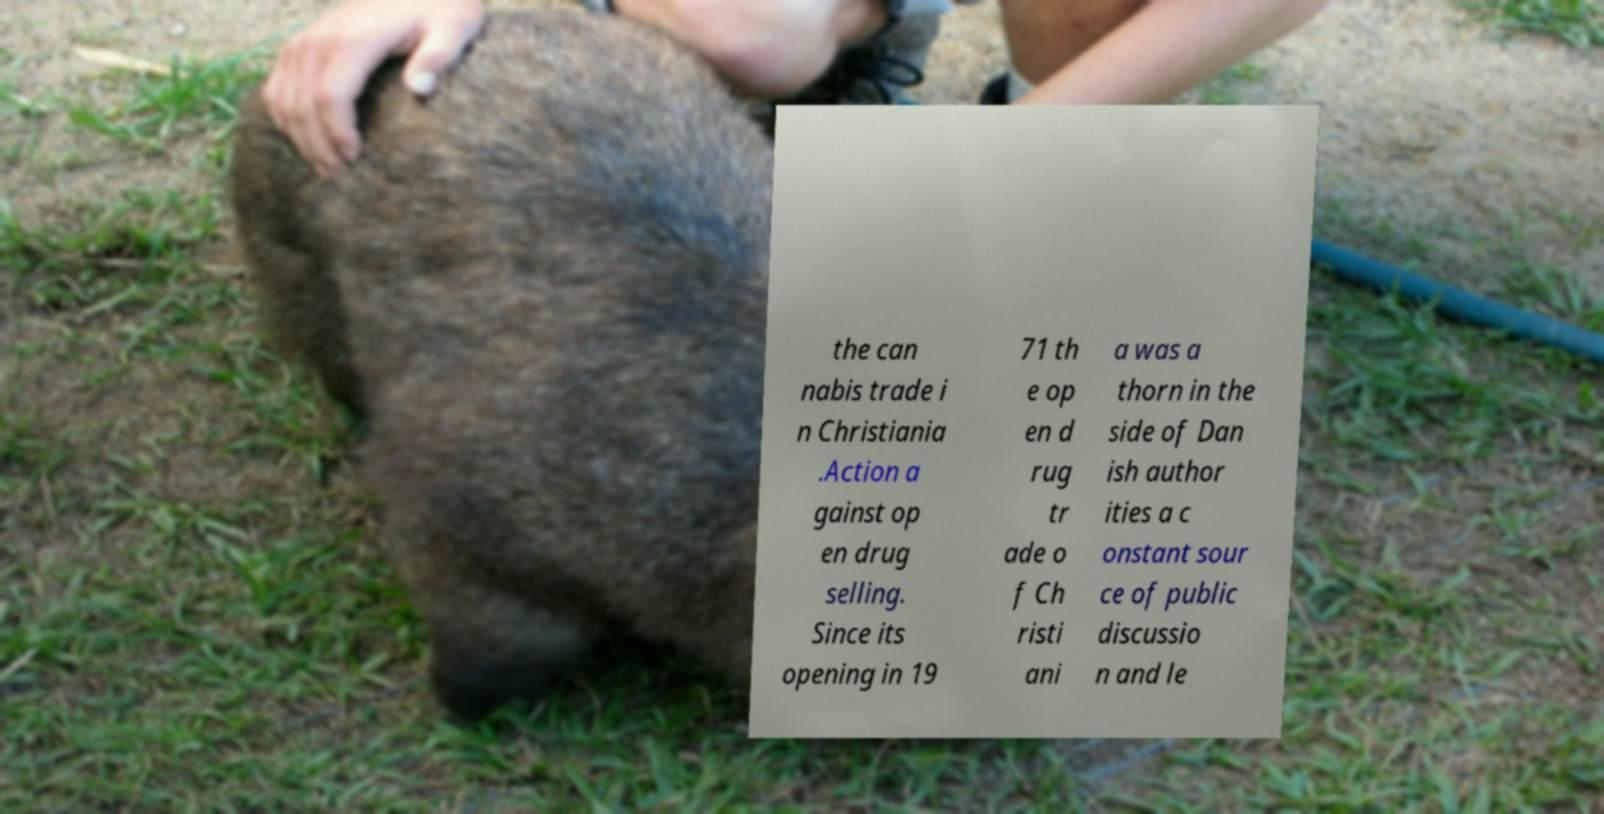Please identify and transcribe the text found in this image. the can nabis trade i n Christiania .Action a gainst op en drug selling. Since its opening in 19 71 th e op en d rug tr ade o f Ch risti ani a was a thorn in the side of Dan ish author ities a c onstant sour ce of public discussio n and le 